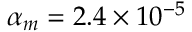Convert formula to latex. <formula><loc_0><loc_0><loc_500><loc_500>\alpha _ { m } = 2 . 4 \times 1 0 ^ { - 5 }</formula> 